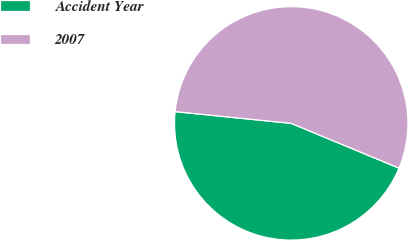<chart> <loc_0><loc_0><loc_500><loc_500><pie_chart><fcel>Accident Year<fcel>2007<nl><fcel>45.34%<fcel>54.66%<nl></chart> 